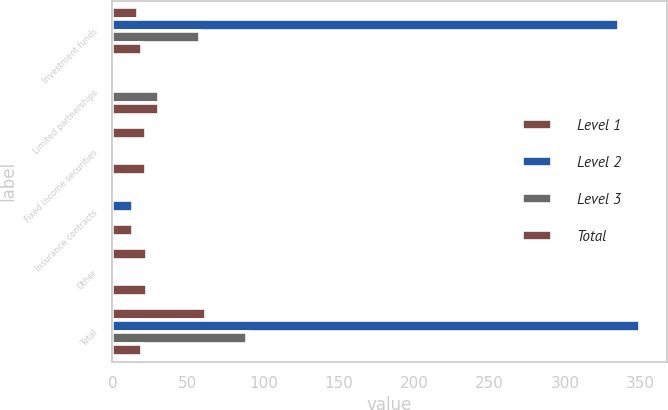<chart> <loc_0><loc_0><loc_500><loc_500><stacked_bar_chart><ecel><fcel>Investment funds<fcel>Limited partnerships<fcel>Fixed income securities<fcel>Insurance contracts<fcel>Other<fcel>Total<nl><fcel>Level 1<fcel>16.8<fcel>0<fcel>22.1<fcel>0<fcel>23<fcel>61.9<nl><fcel>Level 2<fcel>335.8<fcel>0<fcel>0.4<fcel>13.7<fcel>0<fcel>349.9<nl><fcel>Level 3<fcel>57.9<fcel>31<fcel>0<fcel>0<fcel>0<fcel>88.9<nl><fcel>Total<fcel>19.45<fcel>31<fcel>22.5<fcel>13.7<fcel>23<fcel>19.45<nl></chart> 